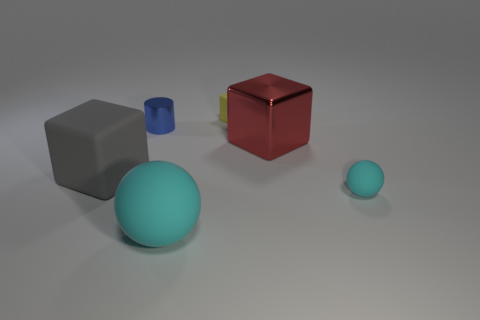Is there a small blue thing of the same shape as the tiny cyan thing?
Provide a succinct answer. No. Is the size of the metal object that is in front of the blue shiny object the same as the rubber sphere that is on the left side of the tiny cyan rubber ball?
Provide a short and direct response. Yes. Are there more tiny blue metal objects than big yellow rubber blocks?
Ensure brevity in your answer.  Yes. How many red blocks have the same material as the cylinder?
Offer a terse response. 1. Does the blue metallic thing have the same shape as the gray rubber thing?
Provide a succinct answer. No. There is a block in front of the large object that is to the right of the matte block that is behind the small metallic object; what is its size?
Your answer should be compact. Large. Are there any rubber things in front of the cyan matte sphere that is on the left side of the tiny cyan rubber object?
Your answer should be compact. No. How many small matte objects are behind the cyan rubber ball in front of the cyan object to the right of the big cyan object?
Provide a short and direct response. 2. What is the color of the small object that is to the right of the blue thing and on the left side of the small cyan rubber thing?
Offer a terse response. Yellow. How many large cubes have the same color as the small metal object?
Your answer should be compact. 0. 